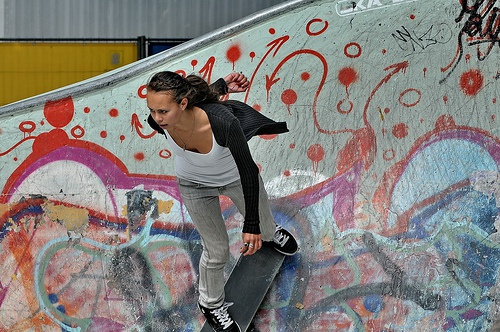Describe the objects in this image and their specific colors. I can see people in darkgray, black, gray, and brown tones and skateboard in darkgray, black, gray, and purple tones in this image. 